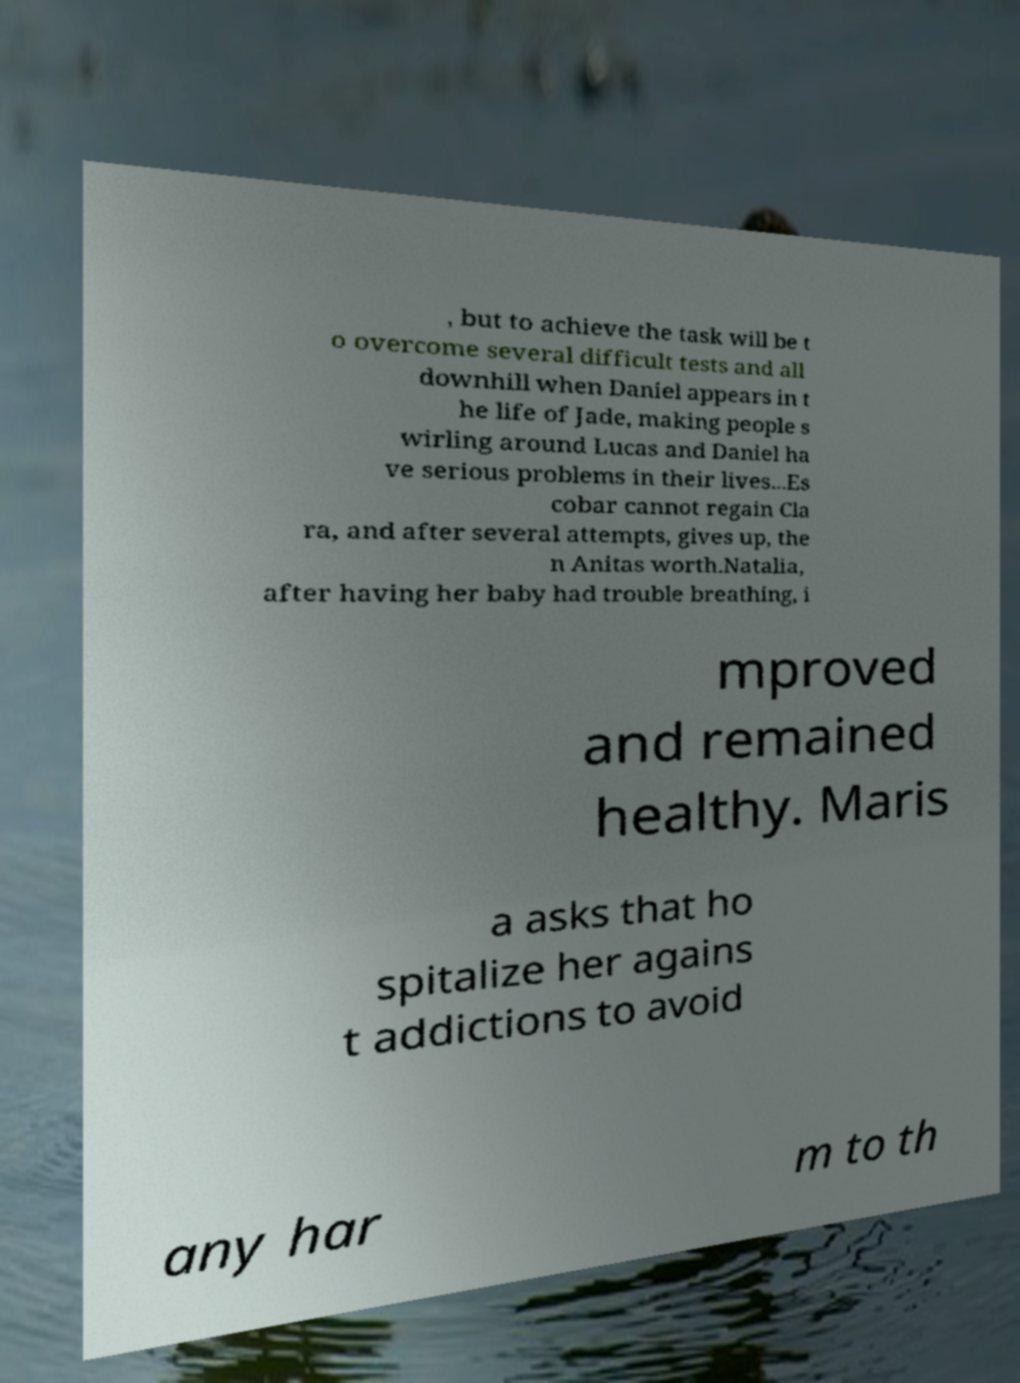Could you extract and type out the text from this image? , but to achieve the task will be t o overcome several difficult tests and all downhill when Daniel appears in t he life of Jade, making people s wirling around Lucas and Daniel ha ve serious problems in their lives...Es cobar cannot regain Cla ra, and after several attempts, gives up, the n Anitas worth.Natalia, after having her baby had trouble breathing, i mproved and remained healthy. Maris a asks that ho spitalize her agains t addictions to avoid any har m to th 